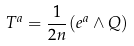<formula> <loc_0><loc_0><loc_500><loc_500>T ^ { a } = \frac { 1 } { 2 n } ( e ^ { a } \wedge Q )</formula> 